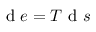<formula> <loc_0><loc_0><loc_500><loc_500>d e = T d s</formula> 